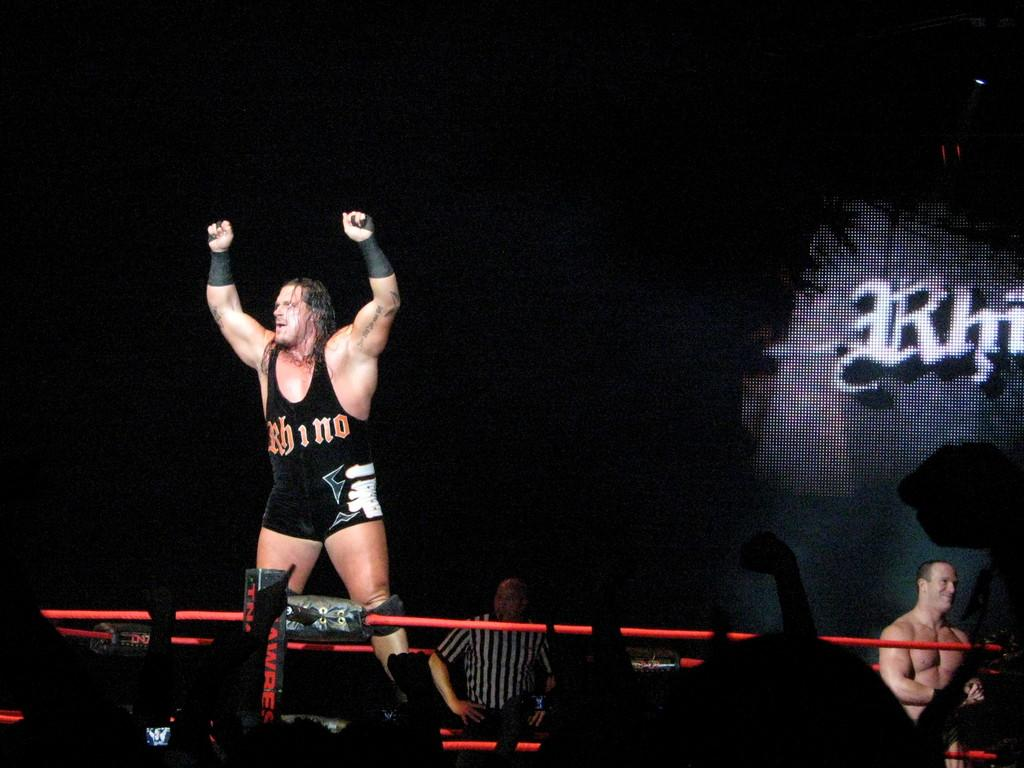<image>
Create a compact narrative representing the image presented. A wrestler with Rhino on his uniform stand with his arms raised in the air. 